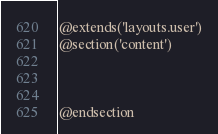Convert code to text. <code><loc_0><loc_0><loc_500><loc_500><_PHP_>@extends('layouts.user')
@section('content')



@endsection</code> 